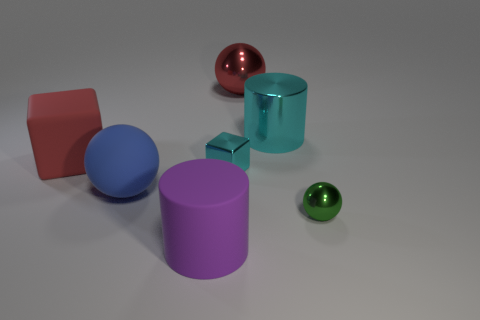Add 2 large balls. How many objects exist? 9 Subtract all cylinders. How many objects are left? 5 Subtract 1 red balls. How many objects are left? 6 Subtract all small gray metallic objects. Subtract all small metal spheres. How many objects are left? 6 Add 6 purple cylinders. How many purple cylinders are left? 7 Add 2 blue matte things. How many blue matte things exist? 3 